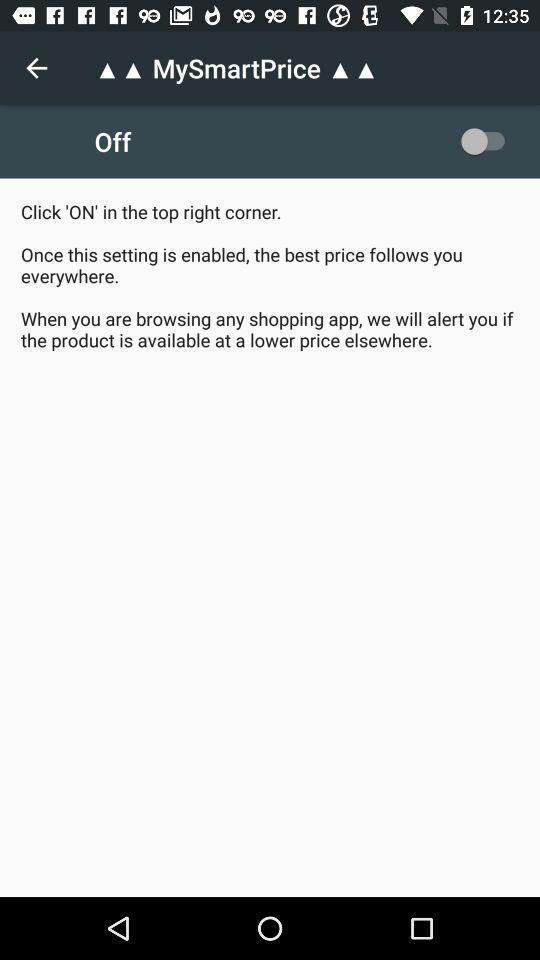Please provide a description for this image. Screen shows smart price. 